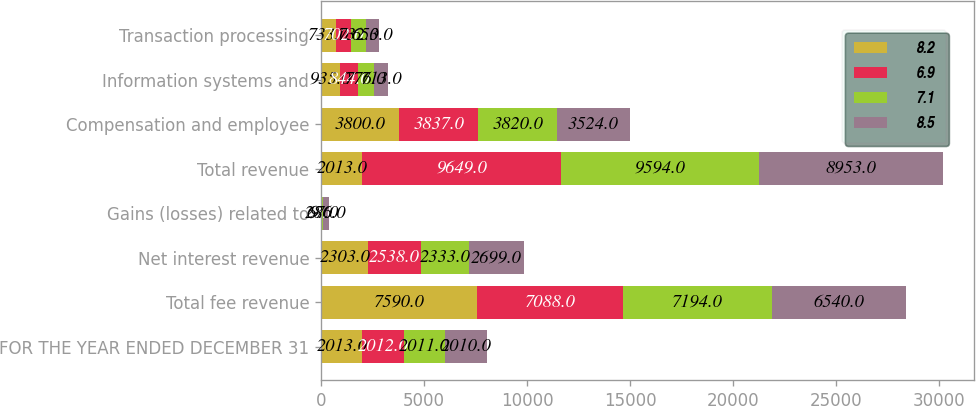Convert chart to OTSL. <chart><loc_0><loc_0><loc_500><loc_500><stacked_bar_chart><ecel><fcel>FOR THE YEAR ENDED DECEMBER 31<fcel>Total fee revenue<fcel>Net interest revenue<fcel>Gains (losses) related to<fcel>Total revenue<fcel>Compensation and employee<fcel>Information systems and<fcel>Transaction processing<nl><fcel>8.2<fcel>2013<fcel>7590<fcel>2303<fcel>9<fcel>2013<fcel>3800<fcel>935<fcel>733<nl><fcel>6.9<fcel>2012<fcel>7088<fcel>2538<fcel>23<fcel>9649<fcel>3837<fcel>844<fcel>702<nl><fcel>7.1<fcel>2011<fcel>7194<fcel>2333<fcel>67<fcel>9594<fcel>3820<fcel>776<fcel>732<nl><fcel>8.5<fcel>2010<fcel>6540<fcel>2699<fcel>286<fcel>8953<fcel>3524<fcel>713<fcel>653<nl></chart> 